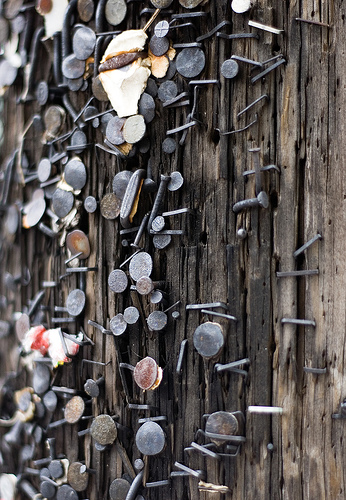<image>
Can you confirm if the nail is in the wood? Yes. The nail is contained within or inside the wood, showing a containment relationship. Is the tools to the left of the door? No. The tools is not to the left of the door. From this viewpoint, they have a different horizontal relationship. 